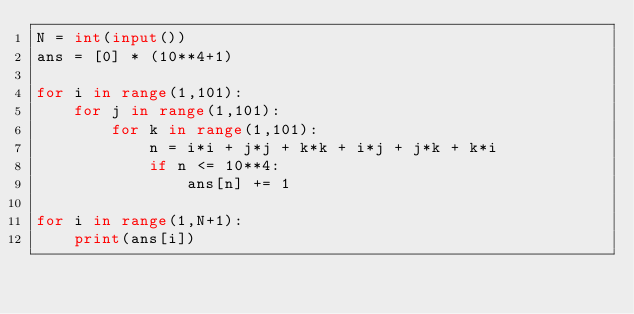<code> <loc_0><loc_0><loc_500><loc_500><_Python_>N = int(input())
ans = [0] * (10**4+1)

for i in range(1,101):
    for j in range(1,101):
        for k in range(1,101):
            n = i*i + j*j + k*k + i*j + j*k + k*i
            if n <= 10**4:
                ans[n] += 1

for i in range(1,N+1):
    print(ans[i])
</code> 